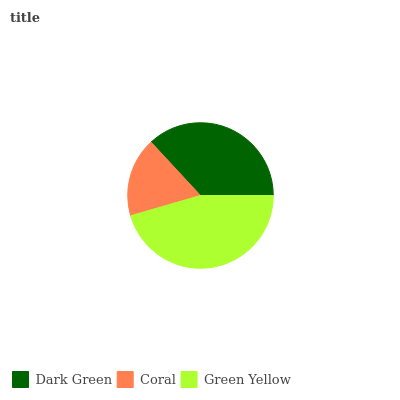Is Coral the minimum?
Answer yes or no. Yes. Is Green Yellow the maximum?
Answer yes or no. Yes. Is Green Yellow the minimum?
Answer yes or no. No. Is Coral the maximum?
Answer yes or no. No. Is Green Yellow greater than Coral?
Answer yes or no. Yes. Is Coral less than Green Yellow?
Answer yes or no. Yes. Is Coral greater than Green Yellow?
Answer yes or no. No. Is Green Yellow less than Coral?
Answer yes or no. No. Is Dark Green the high median?
Answer yes or no. Yes. Is Dark Green the low median?
Answer yes or no. Yes. Is Green Yellow the high median?
Answer yes or no. No. Is Green Yellow the low median?
Answer yes or no. No. 